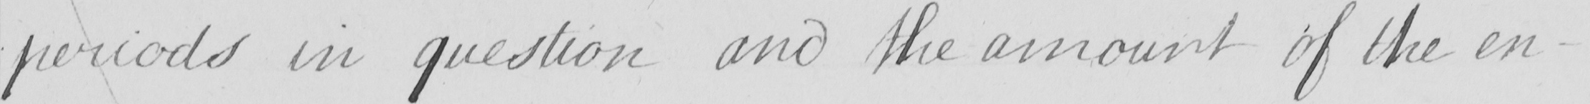What is written in this line of handwriting? periods in question and the amount of the en- 